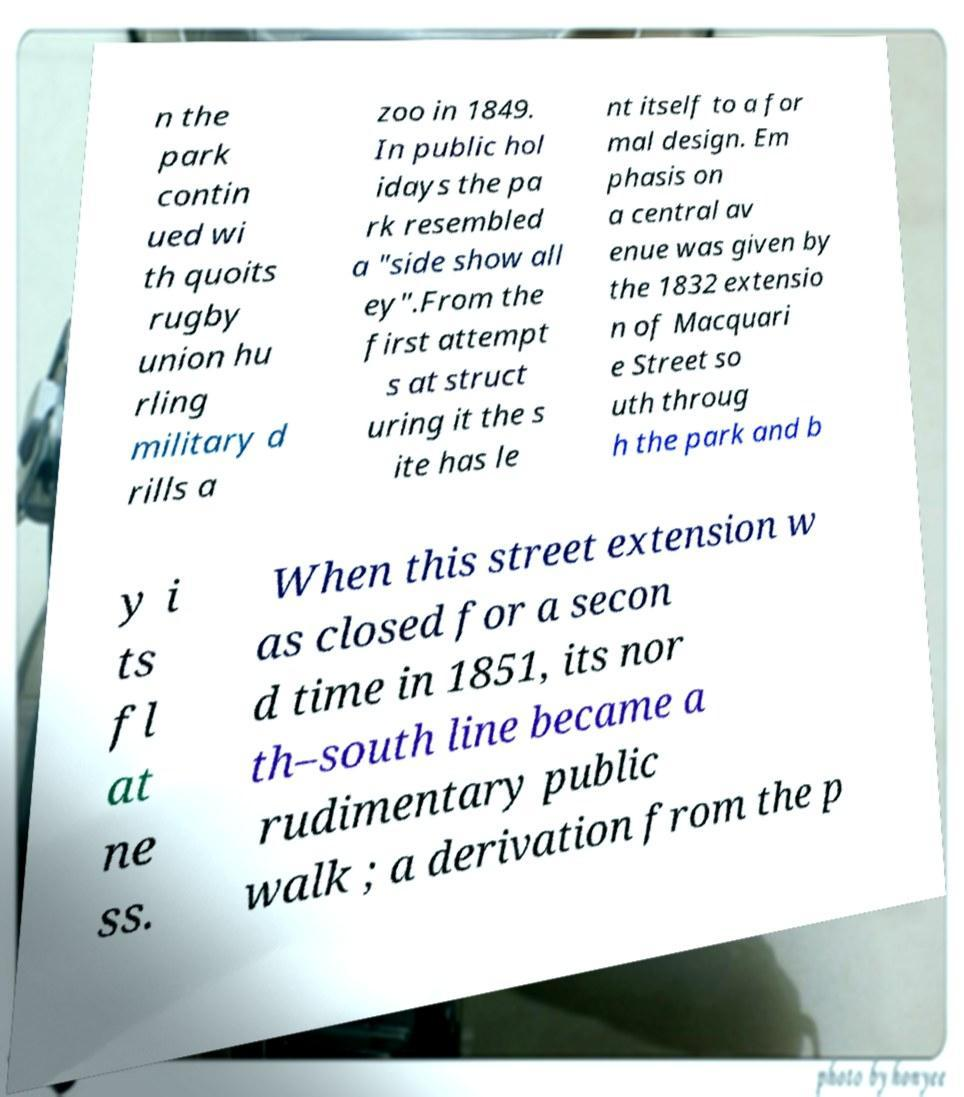What messages or text are displayed in this image? I need them in a readable, typed format. n the park contin ued wi th quoits rugby union hu rling military d rills a zoo in 1849. In public hol idays the pa rk resembled a "side show all ey".From the first attempt s at struct uring it the s ite has le nt itself to a for mal design. Em phasis on a central av enue was given by the 1832 extensio n of Macquari e Street so uth throug h the park and b y i ts fl at ne ss. When this street extension w as closed for a secon d time in 1851, its nor th–south line became a rudimentary public walk ; a derivation from the p 